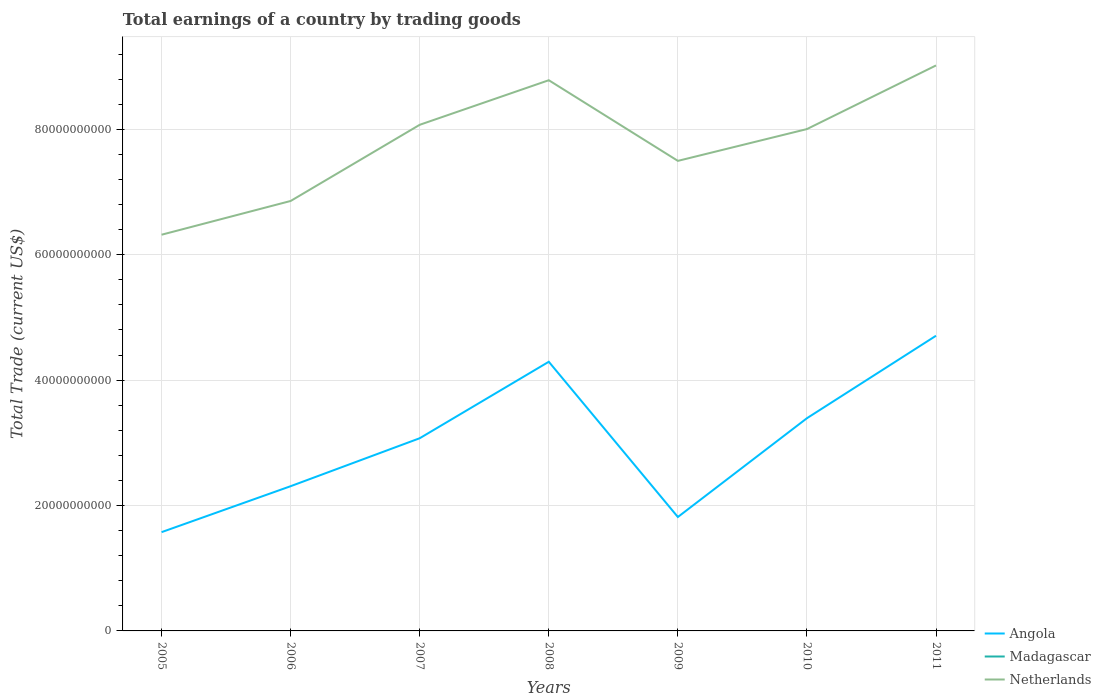Is the number of lines equal to the number of legend labels?
Make the answer very short. No. Across all years, what is the maximum total earnings in Netherlands?
Make the answer very short. 6.32e+1. What is the total total earnings in Netherlands in the graph?
Give a very brief answer. -1.52e+1. What is the difference between the highest and the second highest total earnings in Netherlands?
Offer a very short reply. 2.70e+1. How many lines are there?
Your answer should be compact. 2. Are the values on the major ticks of Y-axis written in scientific E-notation?
Provide a short and direct response. No. Does the graph contain any zero values?
Give a very brief answer. Yes. Where does the legend appear in the graph?
Give a very brief answer. Bottom right. What is the title of the graph?
Give a very brief answer. Total earnings of a country by trading goods. What is the label or title of the X-axis?
Offer a very short reply. Years. What is the label or title of the Y-axis?
Ensure brevity in your answer.  Total Trade (current US$). What is the Total Trade (current US$) in Angola in 2005?
Make the answer very short. 1.58e+1. What is the Total Trade (current US$) in Madagascar in 2005?
Your answer should be very brief. 0. What is the Total Trade (current US$) in Netherlands in 2005?
Provide a succinct answer. 6.32e+1. What is the Total Trade (current US$) of Angola in 2006?
Your answer should be compact. 2.31e+1. What is the Total Trade (current US$) of Madagascar in 2006?
Provide a short and direct response. 0. What is the Total Trade (current US$) in Netherlands in 2006?
Your answer should be compact. 6.86e+1. What is the Total Trade (current US$) of Angola in 2007?
Keep it short and to the point. 3.07e+1. What is the Total Trade (current US$) of Netherlands in 2007?
Give a very brief answer. 8.07e+1. What is the Total Trade (current US$) of Angola in 2008?
Make the answer very short. 4.29e+1. What is the Total Trade (current US$) of Madagascar in 2008?
Give a very brief answer. 0. What is the Total Trade (current US$) in Netherlands in 2008?
Give a very brief answer. 8.78e+1. What is the Total Trade (current US$) of Angola in 2009?
Provide a succinct answer. 1.82e+1. What is the Total Trade (current US$) in Netherlands in 2009?
Provide a short and direct response. 7.50e+1. What is the Total Trade (current US$) in Angola in 2010?
Offer a terse response. 3.39e+1. What is the Total Trade (current US$) in Madagascar in 2010?
Ensure brevity in your answer.  0. What is the Total Trade (current US$) in Netherlands in 2010?
Give a very brief answer. 8.00e+1. What is the Total Trade (current US$) in Angola in 2011?
Your answer should be compact. 4.71e+1. What is the Total Trade (current US$) of Madagascar in 2011?
Your response must be concise. 0. What is the Total Trade (current US$) of Netherlands in 2011?
Your response must be concise. 9.02e+1. Across all years, what is the maximum Total Trade (current US$) in Angola?
Give a very brief answer. 4.71e+1. Across all years, what is the maximum Total Trade (current US$) of Netherlands?
Keep it short and to the point. 9.02e+1. Across all years, what is the minimum Total Trade (current US$) in Angola?
Make the answer very short. 1.58e+1. Across all years, what is the minimum Total Trade (current US$) of Netherlands?
Offer a very short reply. 6.32e+1. What is the total Total Trade (current US$) in Angola in the graph?
Your answer should be compact. 2.12e+11. What is the total Total Trade (current US$) of Madagascar in the graph?
Keep it short and to the point. 0. What is the total Total Trade (current US$) in Netherlands in the graph?
Provide a succinct answer. 5.46e+11. What is the difference between the Total Trade (current US$) of Angola in 2005 and that in 2006?
Your response must be concise. -7.33e+09. What is the difference between the Total Trade (current US$) of Netherlands in 2005 and that in 2006?
Make the answer very short. -5.38e+09. What is the difference between the Total Trade (current US$) in Angola in 2005 and that in 2007?
Your answer should be very brief. -1.50e+1. What is the difference between the Total Trade (current US$) in Netherlands in 2005 and that in 2007?
Offer a very short reply. -1.75e+1. What is the difference between the Total Trade (current US$) in Angola in 2005 and that in 2008?
Ensure brevity in your answer.  -2.72e+1. What is the difference between the Total Trade (current US$) in Netherlands in 2005 and that in 2008?
Provide a short and direct response. -2.46e+1. What is the difference between the Total Trade (current US$) in Angola in 2005 and that in 2009?
Offer a terse response. -2.41e+09. What is the difference between the Total Trade (current US$) in Netherlands in 2005 and that in 2009?
Offer a terse response. -1.18e+1. What is the difference between the Total Trade (current US$) of Angola in 2005 and that in 2010?
Keep it short and to the point. -1.82e+1. What is the difference between the Total Trade (current US$) in Netherlands in 2005 and that in 2010?
Keep it short and to the point. -1.69e+1. What is the difference between the Total Trade (current US$) in Angola in 2005 and that in 2011?
Your answer should be compact. -3.13e+1. What is the difference between the Total Trade (current US$) in Netherlands in 2005 and that in 2011?
Make the answer very short. -2.70e+1. What is the difference between the Total Trade (current US$) of Angola in 2006 and that in 2007?
Your response must be concise. -7.65e+09. What is the difference between the Total Trade (current US$) in Netherlands in 2006 and that in 2007?
Provide a succinct answer. -1.22e+1. What is the difference between the Total Trade (current US$) of Angola in 2006 and that in 2008?
Keep it short and to the point. -1.98e+1. What is the difference between the Total Trade (current US$) in Netherlands in 2006 and that in 2008?
Give a very brief answer. -1.93e+1. What is the difference between the Total Trade (current US$) of Angola in 2006 and that in 2009?
Keep it short and to the point. 4.92e+09. What is the difference between the Total Trade (current US$) in Netherlands in 2006 and that in 2009?
Give a very brief answer. -6.40e+09. What is the difference between the Total Trade (current US$) in Angola in 2006 and that in 2010?
Offer a terse response. -1.08e+1. What is the difference between the Total Trade (current US$) of Netherlands in 2006 and that in 2010?
Your answer should be compact. -1.15e+1. What is the difference between the Total Trade (current US$) of Angola in 2006 and that in 2011?
Keep it short and to the point. -2.40e+1. What is the difference between the Total Trade (current US$) of Netherlands in 2006 and that in 2011?
Your answer should be very brief. -2.16e+1. What is the difference between the Total Trade (current US$) of Angola in 2007 and that in 2008?
Provide a short and direct response. -1.22e+1. What is the difference between the Total Trade (current US$) in Netherlands in 2007 and that in 2008?
Offer a very short reply. -7.11e+09. What is the difference between the Total Trade (current US$) in Angola in 2007 and that in 2009?
Make the answer very short. 1.26e+1. What is the difference between the Total Trade (current US$) of Netherlands in 2007 and that in 2009?
Offer a terse response. 5.76e+09. What is the difference between the Total Trade (current US$) in Angola in 2007 and that in 2010?
Give a very brief answer. -3.19e+09. What is the difference between the Total Trade (current US$) in Netherlands in 2007 and that in 2010?
Ensure brevity in your answer.  6.83e+08. What is the difference between the Total Trade (current US$) of Angola in 2007 and that in 2011?
Your answer should be very brief. -1.63e+1. What is the difference between the Total Trade (current US$) in Netherlands in 2007 and that in 2011?
Ensure brevity in your answer.  -9.47e+09. What is the difference between the Total Trade (current US$) of Angola in 2008 and that in 2009?
Give a very brief answer. 2.48e+1. What is the difference between the Total Trade (current US$) in Netherlands in 2008 and that in 2009?
Ensure brevity in your answer.  1.29e+1. What is the difference between the Total Trade (current US$) in Angola in 2008 and that in 2010?
Provide a short and direct response. 9.00e+09. What is the difference between the Total Trade (current US$) of Netherlands in 2008 and that in 2010?
Your answer should be compact. 7.79e+09. What is the difference between the Total Trade (current US$) of Angola in 2008 and that in 2011?
Provide a short and direct response. -4.15e+09. What is the difference between the Total Trade (current US$) in Netherlands in 2008 and that in 2011?
Make the answer very short. -2.36e+09. What is the difference between the Total Trade (current US$) of Angola in 2009 and that in 2010?
Make the answer very short. -1.58e+1. What is the difference between the Total Trade (current US$) of Netherlands in 2009 and that in 2010?
Provide a succinct answer. -5.07e+09. What is the difference between the Total Trade (current US$) of Angola in 2009 and that in 2011?
Make the answer very short. -2.89e+1. What is the difference between the Total Trade (current US$) in Netherlands in 2009 and that in 2011?
Keep it short and to the point. -1.52e+1. What is the difference between the Total Trade (current US$) of Angola in 2010 and that in 2011?
Provide a succinct answer. -1.32e+1. What is the difference between the Total Trade (current US$) of Netherlands in 2010 and that in 2011?
Make the answer very short. -1.01e+1. What is the difference between the Total Trade (current US$) of Angola in 2005 and the Total Trade (current US$) of Netherlands in 2006?
Offer a very short reply. -5.28e+1. What is the difference between the Total Trade (current US$) in Angola in 2005 and the Total Trade (current US$) in Netherlands in 2007?
Provide a short and direct response. -6.50e+1. What is the difference between the Total Trade (current US$) of Angola in 2005 and the Total Trade (current US$) of Netherlands in 2008?
Offer a very short reply. -7.21e+1. What is the difference between the Total Trade (current US$) in Angola in 2005 and the Total Trade (current US$) in Netherlands in 2009?
Provide a short and direct response. -5.92e+1. What is the difference between the Total Trade (current US$) of Angola in 2005 and the Total Trade (current US$) of Netherlands in 2010?
Your answer should be compact. -6.43e+1. What is the difference between the Total Trade (current US$) in Angola in 2005 and the Total Trade (current US$) in Netherlands in 2011?
Your response must be concise. -7.44e+1. What is the difference between the Total Trade (current US$) in Angola in 2006 and the Total Trade (current US$) in Netherlands in 2007?
Ensure brevity in your answer.  -5.76e+1. What is the difference between the Total Trade (current US$) of Angola in 2006 and the Total Trade (current US$) of Netherlands in 2008?
Offer a terse response. -6.48e+1. What is the difference between the Total Trade (current US$) of Angola in 2006 and the Total Trade (current US$) of Netherlands in 2009?
Your response must be concise. -5.19e+1. What is the difference between the Total Trade (current US$) of Angola in 2006 and the Total Trade (current US$) of Netherlands in 2010?
Offer a very short reply. -5.70e+1. What is the difference between the Total Trade (current US$) of Angola in 2006 and the Total Trade (current US$) of Netherlands in 2011?
Make the answer very short. -6.71e+1. What is the difference between the Total Trade (current US$) in Angola in 2007 and the Total Trade (current US$) in Netherlands in 2008?
Offer a terse response. -5.71e+1. What is the difference between the Total Trade (current US$) in Angola in 2007 and the Total Trade (current US$) in Netherlands in 2009?
Offer a very short reply. -4.42e+1. What is the difference between the Total Trade (current US$) of Angola in 2007 and the Total Trade (current US$) of Netherlands in 2010?
Make the answer very short. -4.93e+1. What is the difference between the Total Trade (current US$) of Angola in 2007 and the Total Trade (current US$) of Netherlands in 2011?
Your answer should be very brief. -5.95e+1. What is the difference between the Total Trade (current US$) in Angola in 2008 and the Total Trade (current US$) in Netherlands in 2009?
Offer a very short reply. -3.20e+1. What is the difference between the Total Trade (current US$) of Angola in 2008 and the Total Trade (current US$) of Netherlands in 2010?
Ensure brevity in your answer.  -3.71e+1. What is the difference between the Total Trade (current US$) of Angola in 2008 and the Total Trade (current US$) of Netherlands in 2011?
Offer a very short reply. -4.73e+1. What is the difference between the Total Trade (current US$) of Angola in 2009 and the Total Trade (current US$) of Netherlands in 2010?
Your response must be concise. -6.19e+1. What is the difference between the Total Trade (current US$) in Angola in 2009 and the Total Trade (current US$) in Netherlands in 2011?
Ensure brevity in your answer.  -7.20e+1. What is the difference between the Total Trade (current US$) of Angola in 2010 and the Total Trade (current US$) of Netherlands in 2011?
Give a very brief answer. -5.63e+1. What is the average Total Trade (current US$) of Angola per year?
Your response must be concise. 3.02e+1. What is the average Total Trade (current US$) of Madagascar per year?
Offer a very short reply. 0. What is the average Total Trade (current US$) in Netherlands per year?
Provide a succinct answer. 7.79e+1. In the year 2005, what is the difference between the Total Trade (current US$) of Angola and Total Trade (current US$) of Netherlands?
Your answer should be compact. -4.74e+1. In the year 2006, what is the difference between the Total Trade (current US$) in Angola and Total Trade (current US$) in Netherlands?
Keep it short and to the point. -4.55e+1. In the year 2007, what is the difference between the Total Trade (current US$) of Angola and Total Trade (current US$) of Netherlands?
Your answer should be compact. -5.00e+1. In the year 2008, what is the difference between the Total Trade (current US$) of Angola and Total Trade (current US$) of Netherlands?
Ensure brevity in your answer.  -4.49e+1. In the year 2009, what is the difference between the Total Trade (current US$) in Angola and Total Trade (current US$) in Netherlands?
Ensure brevity in your answer.  -5.68e+1. In the year 2010, what is the difference between the Total Trade (current US$) in Angola and Total Trade (current US$) in Netherlands?
Offer a very short reply. -4.61e+1. In the year 2011, what is the difference between the Total Trade (current US$) of Angola and Total Trade (current US$) of Netherlands?
Ensure brevity in your answer.  -4.31e+1. What is the ratio of the Total Trade (current US$) in Angola in 2005 to that in 2006?
Your answer should be very brief. 0.68. What is the ratio of the Total Trade (current US$) of Netherlands in 2005 to that in 2006?
Provide a short and direct response. 0.92. What is the ratio of the Total Trade (current US$) of Angola in 2005 to that in 2007?
Ensure brevity in your answer.  0.51. What is the ratio of the Total Trade (current US$) in Netherlands in 2005 to that in 2007?
Your response must be concise. 0.78. What is the ratio of the Total Trade (current US$) of Angola in 2005 to that in 2008?
Provide a succinct answer. 0.37. What is the ratio of the Total Trade (current US$) in Netherlands in 2005 to that in 2008?
Your response must be concise. 0.72. What is the ratio of the Total Trade (current US$) of Angola in 2005 to that in 2009?
Ensure brevity in your answer.  0.87. What is the ratio of the Total Trade (current US$) in Netherlands in 2005 to that in 2009?
Keep it short and to the point. 0.84. What is the ratio of the Total Trade (current US$) of Angola in 2005 to that in 2010?
Offer a very short reply. 0.46. What is the ratio of the Total Trade (current US$) of Netherlands in 2005 to that in 2010?
Provide a succinct answer. 0.79. What is the ratio of the Total Trade (current US$) in Angola in 2005 to that in 2011?
Provide a short and direct response. 0.33. What is the ratio of the Total Trade (current US$) in Netherlands in 2005 to that in 2011?
Your answer should be very brief. 0.7. What is the ratio of the Total Trade (current US$) of Angola in 2006 to that in 2007?
Your answer should be very brief. 0.75. What is the ratio of the Total Trade (current US$) in Netherlands in 2006 to that in 2007?
Make the answer very short. 0.85. What is the ratio of the Total Trade (current US$) of Angola in 2006 to that in 2008?
Your response must be concise. 0.54. What is the ratio of the Total Trade (current US$) in Netherlands in 2006 to that in 2008?
Offer a terse response. 0.78. What is the ratio of the Total Trade (current US$) in Angola in 2006 to that in 2009?
Offer a very short reply. 1.27. What is the ratio of the Total Trade (current US$) in Netherlands in 2006 to that in 2009?
Provide a short and direct response. 0.91. What is the ratio of the Total Trade (current US$) in Angola in 2006 to that in 2010?
Make the answer very short. 0.68. What is the ratio of the Total Trade (current US$) in Netherlands in 2006 to that in 2010?
Offer a terse response. 0.86. What is the ratio of the Total Trade (current US$) in Angola in 2006 to that in 2011?
Provide a succinct answer. 0.49. What is the ratio of the Total Trade (current US$) of Netherlands in 2006 to that in 2011?
Ensure brevity in your answer.  0.76. What is the ratio of the Total Trade (current US$) of Angola in 2007 to that in 2008?
Keep it short and to the point. 0.72. What is the ratio of the Total Trade (current US$) of Netherlands in 2007 to that in 2008?
Your answer should be very brief. 0.92. What is the ratio of the Total Trade (current US$) in Angola in 2007 to that in 2009?
Offer a terse response. 1.69. What is the ratio of the Total Trade (current US$) of Netherlands in 2007 to that in 2009?
Make the answer very short. 1.08. What is the ratio of the Total Trade (current US$) of Angola in 2007 to that in 2010?
Ensure brevity in your answer.  0.91. What is the ratio of the Total Trade (current US$) of Netherlands in 2007 to that in 2010?
Offer a terse response. 1.01. What is the ratio of the Total Trade (current US$) in Angola in 2007 to that in 2011?
Your response must be concise. 0.65. What is the ratio of the Total Trade (current US$) in Netherlands in 2007 to that in 2011?
Offer a very short reply. 0.9. What is the ratio of the Total Trade (current US$) in Angola in 2008 to that in 2009?
Your answer should be compact. 2.36. What is the ratio of the Total Trade (current US$) of Netherlands in 2008 to that in 2009?
Make the answer very short. 1.17. What is the ratio of the Total Trade (current US$) in Angola in 2008 to that in 2010?
Make the answer very short. 1.27. What is the ratio of the Total Trade (current US$) of Netherlands in 2008 to that in 2010?
Your answer should be very brief. 1.1. What is the ratio of the Total Trade (current US$) in Angola in 2008 to that in 2011?
Ensure brevity in your answer.  0.91. What is the ratio of the Total Trade (current US$) in Netherlands in 2008 to that in 2011?
Offer a terse response. 0.97. What is the ratio of the Total Trade (current US$) of Angola in 2009 to that in 2010?
Offer a terse response. 0.54. What is the ratio of the Total Trade (current US$) in Netherlands in 2009 to that in 2010?
Your response must be concise. 0.94. What is the ratio of the Total Trade (current US$) in Angola in 2009 to that in 2011?
Your response must be concise. 0.39. What is the ratio of the Total Trade (current US$) of Netherlands in 2009 to that in 2011?
Your response must be concise. 0.83. What is the ratio of the Total Trade (current US$) in Angola in 2010 to that in 2011?
Provide a succinct answer. 0.72. What is the ratio of the Total Trade (current US$) of Netherlands in 2010 to that in 2011?
Your response must be concise. 0.89. What is the difference between the highest and the second highest Total Trade (current US$) of Angola?
Give a very brief answer. 4.15e+09. What is the difference between the highest and the second highest Total Trade (current US$) in Netherlands?
Provide a short and direct response. 2.36e+09. What is the difference between the highest and the lowest Total Trade (current US$) in Angola?
Make the answer very short. 3.13e+1. What is the difference between the highest and the lowest Total Trade (current US$) of Netherlands?
Provide a succinct answer. 2.70e+1. 